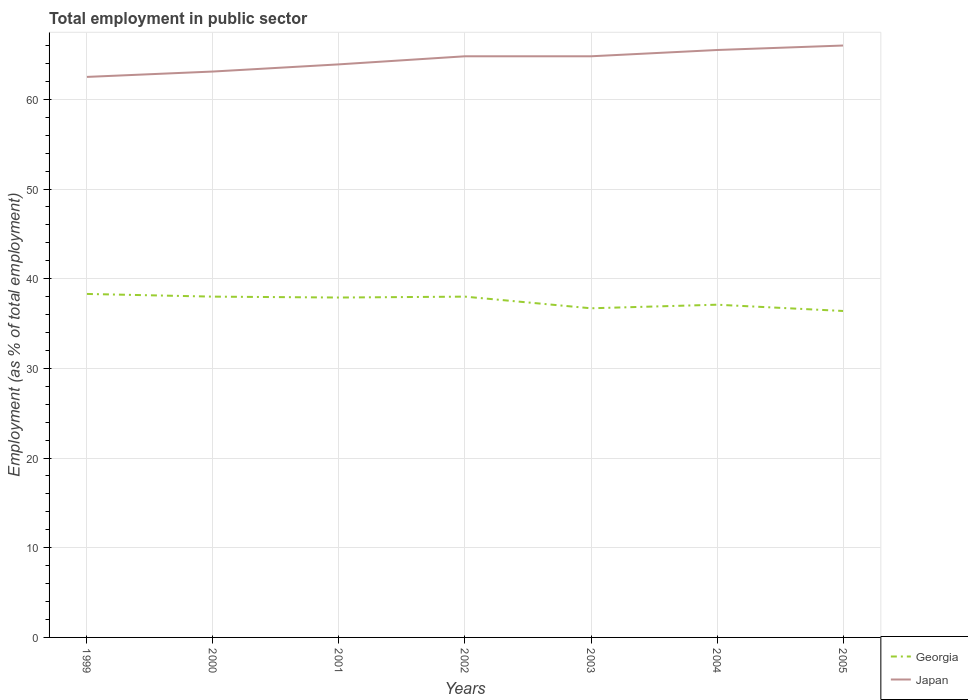How many different coloured lines are there?
Your answer should be very brief. 2. Is the number of lines equal to the number of legend labels?
Provide a succinct answer. Yes. Across all years, what is the maximum employment in public sector in Japan?
Offer a terse response. 62.5. In which year was the employment in public sector in Japan maximum?
Give a very brief answer. 1999. What is the total employment in public sector in Japan in the graph?
Offer a terse response. -0.7. What is the difference between the highest and the second highest employment in public sector in Japan?
Your answer should be very brief. 3.5. What is the difference between the highest and the lowest employment in public sector in Georgia?
Ensure brevity in your answer.  4. Is the employment in public sector in Georgia strictly greater than the employment in public sector in Japan over the years?
Ensure brevity in your answer.  Yes. How many lines are there?
Give a very brief answer. 2. How many years are there in the graph?
Keep it short and to the point. 7. Where does the legend appear in the graph?
Keep it short and to the point. Bottom right. What is the title of the graph?
Offer a terse response. Total employment in public sector. Does "Estonia" appear as one of the legend labels in the graph?
Provide a succinct answer. No. What is the label or title of the Y-axis?
Ensure brevity in your answer.  Employment (as % of total employment). What is the Employment (as % of total employment) of Georgia in 1999?
Ensure brevity in your answer.  38.3. What is the Employment (as % of total employment) in Japan in 1999?
Give a very brief answer. 62.5. What is the Employment (as % of total employment) of Georgia in 2000?
Your answer should be compact. 38. What is the Employment (as % of total employment) of Japan in 2000?
Your answer should be very brief. 63.1. What is the Employment (as % of total employment) in Georgia in 2001?
Your answer should be compact. 37.9. What is the Employment (as % of total employment) in Japan in 2001?
Offer a very short reply. 63.9. What is the Employment (as % of total employment) of Japan in 2002?
Ensure brevity in your answer.  64.8. What is the Employment (as % of total employment) of Georgia in 2003?
Offer a very short reply. 36.7. What is the Employment (as % of total employment) of Japan in 2003?
Your answer should be very brief. 64.8. What is the Employment (as % of total employment) in Georgia in 2004?
Provide a short and direct response. 37.1. What is the Employment (as % of total employment) in Japan in 2004?
Ensure brevity in your answer.  65.5. What is the Employment (as % of total employment) of Georgia in 2005?
Provide a short and direct response. 36.4. Across all years, what is the maximum Employment (as % of total employment) of Georgia?
Keep it short and to the point. 38.3. Across all years, what is the minimum Employment (as % of total employment) of Georgia?
Offer a very short reply. 36.4. Across all years, what is the minimum Employment (as % of total employment) of Japan?
Give a very brief answer. 62.5. What is the total Employment (as % of total employment) of Georgia in the graph?
Ensure brevity in your answer.  262.4. What is the total Employment (as % of total employment) in Japan in the graph?
Your response must be concise. 450.6. What is the difference between the Employment (as % of total employment) of Japan in 1999 and that in 2000?
Offer a very short reply. -0.6. What is the difference between the Employment (as % of total employment) of Georgia in 1999 and that in 2001?
Make the answer very short. 0.4. What is the difference between the Employment (as % of total employment) of Georgia in 1999 and that in 2002?
Provide a succinct answer. 0.3. What is the difference between the Employment (as % of total employment) in Japan in 1999 and that in 2002?
Ensure brevity in your answer.  -2.3. What is the difference between the Employment (as % of total employment) in Georgia in 1999 and that in 2003?
Provide a short and direct response. 1.6. What is the difference between the Employment (as % of total employment) of Georgia in 1999 and that in 2004?
Offer a terse response. 1.2. What is the difference between the Employment (as % of total employment) of Georgia in 1999 and that in 2005?
Your answer should be compact. 1.9. What is the difference between the Employment (as % of total employment) of Japan in 2000 and that in 2003?
Your response must be concise. -1.7. What is the difference between the Employment (as % of total employment) of Georgia in 2000 and that in 2004?
Provide a short and direct response. 0.9. What is the difference between the Employment (as % of total employment) of Japan in 2000 and that in 2004?
Offer a terse response. -2.4. What is the difference between the Employment (as % of total employment) of Georgia in 2000 and that in 2005?
Provide a succinct answer. 1.6. What is the difference between the Employment (as % of total employment) of Japan in 2000 and that in 2005?
Your answer should be very brief. -2.9. What is the difference between the Employment (as % of total employment) in Georgia in 2001 and that in 2002?
Provide a short and direct response. -0.1. What is the difference between the Employment (as % of total employment) in Japan in 2001 and that in 2003?
Your answer should be very brief. -0.9. What is the difference between the Employment (as % of total employment) in Japan in 2001 and that in 2004?
Give a very brief answer. -1.6. What is the difference between the Employment (as % of total employment) of Georgia in 2001 and that in 2005?
Your answer should be very brief. 1.5. What is the difference between the Employment (as % of total employment) in Japan in 2001 and that in 2005?
Offer a terse response. -2.1. What is the difference between the Employment (as % of total employment) in Georgia in 2002 and that in 2004?
Your response must be concise. 0.9. What is the difference between the Employment (as % of total employment) of Georgia in 2003 and that in 2004?
Your response must be concise. -0.4. What is the difference between the Employment (as % of total employment) of Japan in 2003 and that in 2005?
Your answer should be very brief. -1.2. What is the difference between the Employment (as % of total employment) in Georgia in 2004 and that in 2005?
Offer a terse response. 0.7. What is the difference between the Employment (as % of total employment) of Georgia in 1999 and the Employment (as % of total employment) of Japan in 2000?
Provide a short and direct response. -24.8. What is the difference between the Employment (as % of total employment) of Georgia in 1999 and the Employment (as % of total employment) of Japan in 2001?
Your response must be concise. -25.6. What is the difference between the Employment (as % of total employment) of Georgia in 1999 and the Employment (as % of total employment) of Japan in 2002?
Your answer should be compact. -26.5. What is the difference between the Employment (as % of total employment) of Georgia in 1999 and the Employment (as % of total employment) of Japan in 2003?
Offer a very short reply. -26.5. What is the difference between the Employment (as % of total employment) in Georgia in 1999 and the Employment (as % of total employment) in Japan in 2004?
Make the answer very short. -27.2. What is the difference between the Employment (as % of total employment) in Georgia in 1999 and the Employment (as % of total employment) in Japan in 2005?
Ensure brevity in your answer.  -27.7. What is the difference between the Employment (as % of total employment) of Georgia in 2000 and the Employment (as % of total employment) of Japan in 2001?
Offer a terse response. -25.9. What is the difference between the Employment (as % of total employment) of Georgia in 2000 and the Employment (as % of total employment) of Japan in 2002?
Offer a very short reply. -26.8. What is the difference between the Employment (as % of total employment) in Georgia in 2000 and the Employment (as % of total employment) in Japan in 2003?
Your answer should be compact. -26.8. What is the difference between the Employment (as % of total employment) in Georgia in 2000 and the Employment (as % of total employment) in Japan in 2004?
Offer a terse response. -27.5. What is the difference between the Employment (as % of total employment) in Georgia in 2001 and the Employment (as % of total employment) in Japan in 2002?
Provide a succinct answer. -26.9. What is the difference between the Employment (as % of total employment) of Georgia in 2001 and the Employment (as % of total employment) of Japan in 2003?
Give a very brief answer. -26.9. What is the difference between the Employment (as % of total employment) in Georgia in 2001 and the Employment (as % of total employment) in Japan in 2004?
Your answer should be compact. -27.6. What is the difference between the Employment (as % of total employment) of Georgia in 2001 and the Employment (as % of total employment) of Japan in 2005?
Ensure brevity in your answer.  -28.1. What is the difference between the Employment (as % of total employment) in Georgia in 2002 and the Employment (as % of total employment) in Japan in 2003?
Your answer should be very brief. -26.8. What is the difference between the Employment (as % of total employment) in Georgia in 2002 and the Employment (as % of total employment) in Japan in 2004?
Make the answer very short. -27.5. What is the difference between the Employment (as % of total employment) of Georgia in 2003 and the Employment (as % of total employment) of Japan in 2004?
Keep it short and to the point. -28.8. What is the difference between the Employment (as % of total employment) of Georgia in 2003 and the Employment (as % of total employment) of Japan in 2005?
Offer a very short reply. -29.3. What is the difference between the Employment (as % of total employment) in Georgia in 2004 and the Employment (as % of total employment) in Japan in 2005?
Your answer should be compact. -28.9. What is the average Employment (as % of total employment) in Georgia per year?
Make the answer very short. 37.49. What is the average Employment (as % of total employment) of Japan per year?
Your answer should be compact. 64.37. In the year 1999, what is the difference between the Employment (as % of total employment) in Georgia and Employment (as % of total employment) in Japan?
Make the answer very short. -24.2. In the year 2000, what is the difference between the Employment (as % of total employment) of Georgia and Employment (as % of total employment) of Japan?
Your answer should be compact. -25.1. In the year 2002, what is the difference between the Employment (as % of total employment) of Georgia and Employment (as % of total employment) of Japan?
Your response must be concise. -26.8. In the year 2003, what is the difference between the Employment (as % of total employment) in Georgia and Employment (as % of total employment) in Japan?
Keep it short and to the point. -28.1. In the year 2004, what is the difference between the Employment (as % of total employment) of Georgia and Employment (as % of total employment) of Japan?
Your response must be concise. -28.4. In the year 2005, what is the difference between the Employment (as % of total employment) in Georgia and Employment (as % of total employment) in Japan?
Your answer should be very brief. -29.6. What is the ratio of the Employment (as % of total employment) of Georgia in 1999 to that in 2000?
Offer a terse response. 1.01. What is the ratio of the Employment (as % of total employment) in Georgia in 1999 to that in 2001?
Give a very brief answer. 1.01. What is the ratio of the Employment (as % of total employment) of Japan in 1999 to that in 2001?
Offer a terse response. 0.98. What is the ratio of the Employment (as % of total employment) of Georgia in 1999 to that in 2002?
Offer a very short reply. 1.01. What is the ratio of the Employment (as % of total employment) of Japan in 1999 to that in 2002?
Offer a very short reply. 0.96. What is the ratio of the Employment (as % of total employment) in Georgia in 1999 to that in 2003?
Provide a short and direct response. 1.04. What is the ratio of the Employment (as % of total employment) of Japan in 1999 to that in 2003?
Provide a succinct answer. 0.96. What is the ratio of the Employment (as % of total employment) of Georgia in 1999 to that in 2004?
Ensure brevity in your answer.  1.03. What is the ratio of the Employment (as % of total employment) in Japan in 1999 to that in 2004?
Ensure brevity in your answer.  0.95. What is the ratio of the Employment (as % of total employment) in Georgia in 1999 to that in 2005?
Provide a succinct answer. 1.05. What is the ratio of the Employment (as % of total employment) of Japan in 1999 to that in 2005?
Your response must be concise. 0.95. What is the ratio of the Employment (as % of total employment) of Georgia in 2000 to that in 2001?
Give a very brief answer. 1. What is the ratio of the Employment (as % of total employment) of Japan in 2000 to that in 2001?
Ensure brevity in your answer.  0.99. What is the ratio of the Employment (as % of total employment) of Georgia in 2000 to that in 2002?
Provide a short and direct response. 1. What is the ratio of the Employment (as % of total employment) of Japan in 2000 to that in 2002?
Ensure brevity in your answer.  0.97. What is the ratio of the Employment (as % of total employment) in Georgia in 2000 to that in 2003?
Your response must be concise. 1.04. What is the ratio of the Employment (as % of total employment) in Japan in 2000 to that in 2003?
Offer a terse response. 0.97. What is the ratio of the Employment (as % of total employment) of Georgia in 2000 to that in 2004?
Give a very brief answer. 1.02. What is the ratio of the Employment (as % of total employment) in Japan in 2000 to that in 2004?
Ensure brevity in your answer.  0.96. What is the ratio of the Employment (as % of total employment) in Georgia in 2000 to that in 2005?
Make the answer very short. 1.04. What is the ratio of the Employment (as % of total employment) of Japan in 2000 to that in 2005?
Provide a succinct answer. 0.96. What is the ratio of the Employment (as % of total employment) in Japan in 2001 to that in 2002?
Keep it short and to the point. 0.99. What is the ratio of the Employment (as % of total employment) in Georgia in 2001 to that in 2003?
Offer a very short reply. 1.03. What is the ratio of the Employment (as % of total employment) of Japan in 2001 to that in 2003?
Your answer should be very brief. 0.99. What is the ratio of the Employment (as % of total employment) of Georgia in 2001 to that in 2004?
Make the answer very short. 1.02. What is the ratio of the Employment (as % of total employment) of Japan in 2001 to that in 2004?
Make the answer very short. 0.98. What is the ratio of the Employment (as % of total employment) of Georgia in 2001 to that in 2005?
Provide a succinct answer. 1.04. What is the ratio of the Employment (as % of total employment) in Japan in 2001 to that in 2005?
Provide a succinct answer. 0.97. What is the ratio of the Employment (as % of total employment) of Georgia in 2002 to that in 2003?
Make the answer very short. 1.04. What is the ratio of the Employment (as % of total employment) in Japan in 2002 to that in 2003?
Your answer should be compact. 1. What is the ratio of the Employment (as % of total employment) in Georgia in 2002 to that in 2004?
Your answer should be compact. 1.02. What is the ratio of the Employment (as % of total employment) in Japan in 2002 to that in 2004?
Provide a short and direct response. 0.99. What is the ratio of the Employment (as % of total employment) of Georgia in 2002 to that in 2005?
Your answer should be very brief. 1.04. What is the ratio of the Employment (as % of total employment) of Japan in 2002 to that in 2005?
Make the answer very short. 0.98. What is the ratio of the Employment (as % of total employment) in Georgia in 2003 to that in 2004?
Offer a very short reply. 0.99. What is the ratio of the Employment (as % of total employment) in Japan in 2003 to that in 2004?
Your answer should be very brief. 0.99. What is the ratio of the Employment (as % of total employment) in Georgia in 2003 to that in 2005?
Make the answer very short. 1.01. What is the ratio of the Employment (as % of total employment) of Japan in 2003 to that in 2005?
Make the answer very short. 0.98. What is the ratio of the Employment (as % of total employment) in Georgia in 2004 to that in 2005?
Give a very brief answer. 1.02. What is the ratio of the Employment (as % of total employment) in Japan in 2004 to that in 2005?
Ensure brevity in your answer.  0.99. What is the difference between the highest and the second highest Employment (as % of total employment) in Japan?
Provide a succinct answer. 0.5. What is the difference between the highest and the lowest Employment (as % of total employment) of Japan?
Give a very brief answer. 3.5. 